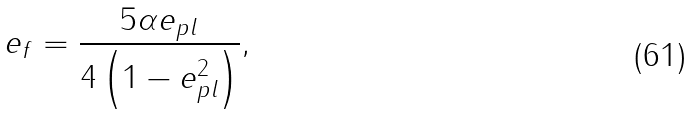Convert formula to latex. <formula><loc_0><loc_0><loc_500><loc_500>e _ { f } = \frac { 5 \alpha e _ { p l } } { 4 \left ( 1 - e _ { p l } ^ { 2 } \right ) } ,</formula> 